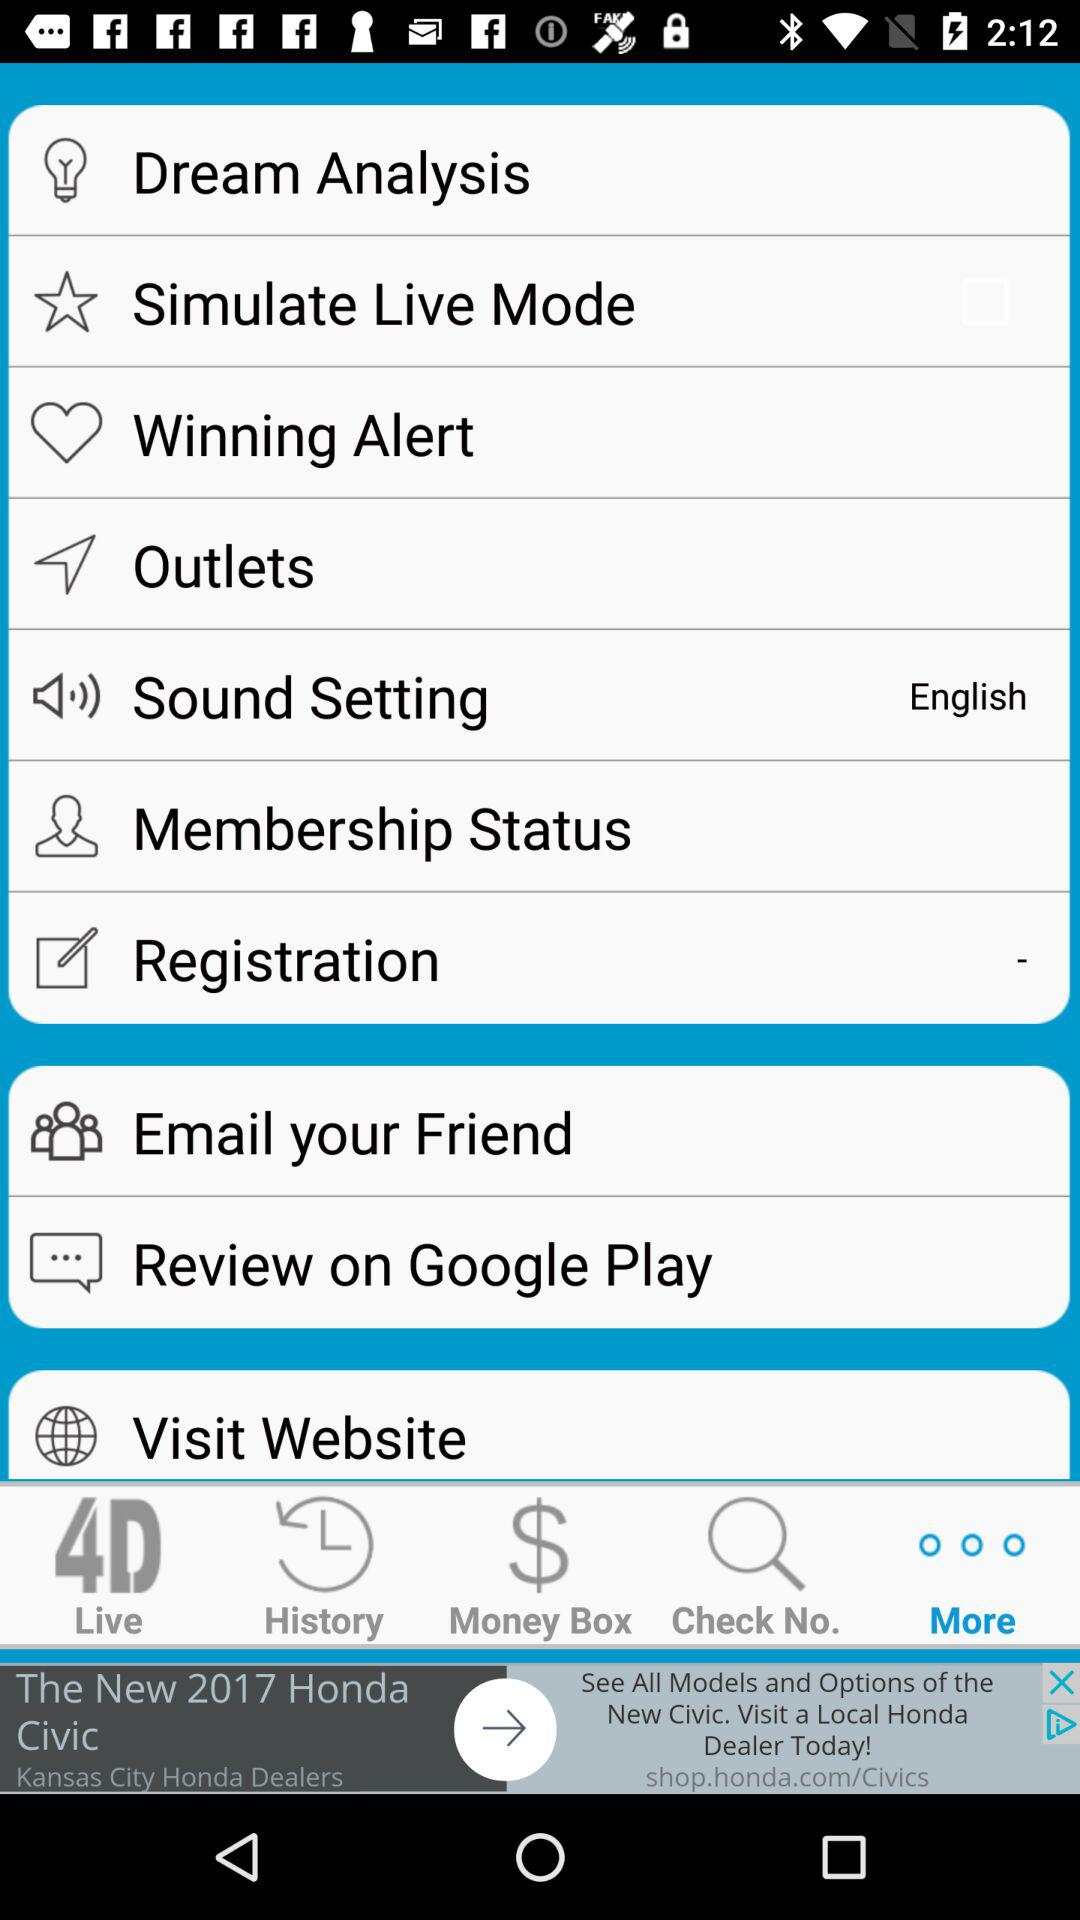Which option is selected? The selected option is "More". 